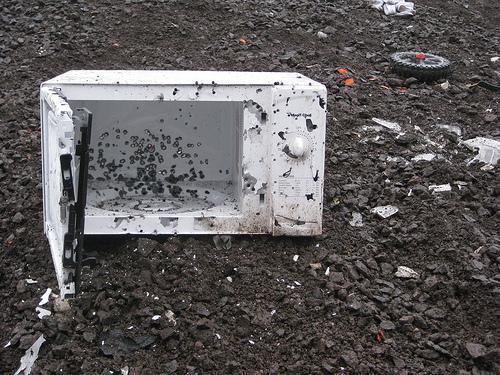How many tires are in the photo?
Give a very brief answer. 1. 